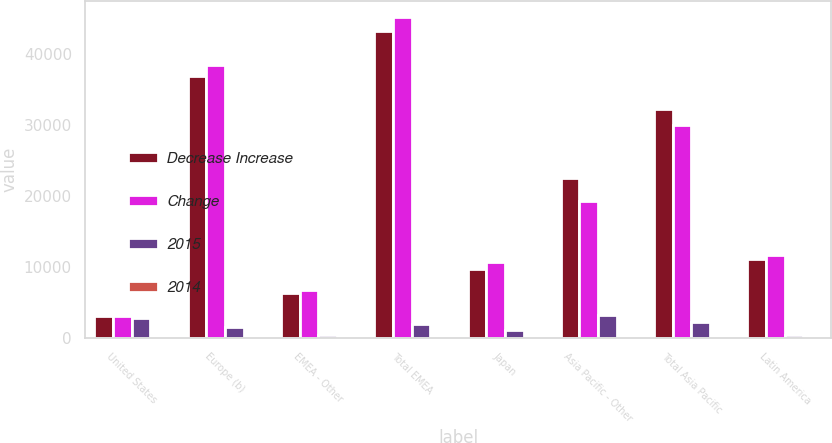Convert chart. <chart><loc_0><loc_0><loc_500><loc_500><stacked_bar_chart><ecel><fcel>United States<fcel>Europe (b)<fcel>EMEA - Other<fcel>Total EMEA<fcel>Japan<fcel>Asia Pacific - Other<fcel>Total Asia Pacific<fcel>Latin America<nl><fcel>Decrease Increase<fcel>3049<fcel>36894<fcel>6393<fcel>43287<fcel>9700<fcel>22558<fcel>32258<fcel>11173<nl><fcel>Change<fcel>3049<fcel>38491<fcel>6832<fcel>45323<fcel>10775<fcel>19299<fcel>30074<fcel>11652<nl><fcel>2015<fcel>2839<fcel>1597<fcel>439<fcel>2036<fcel>1075<fcel>3259<fcel>2184<fcel>479<nl><fcel>2014<fcel>1.7<fcel>4.1<fcel>6.4<fcel>4.5<fcel>10<fcel>16.9<fcel>7.3<fcel>4.1<nl></chart> 